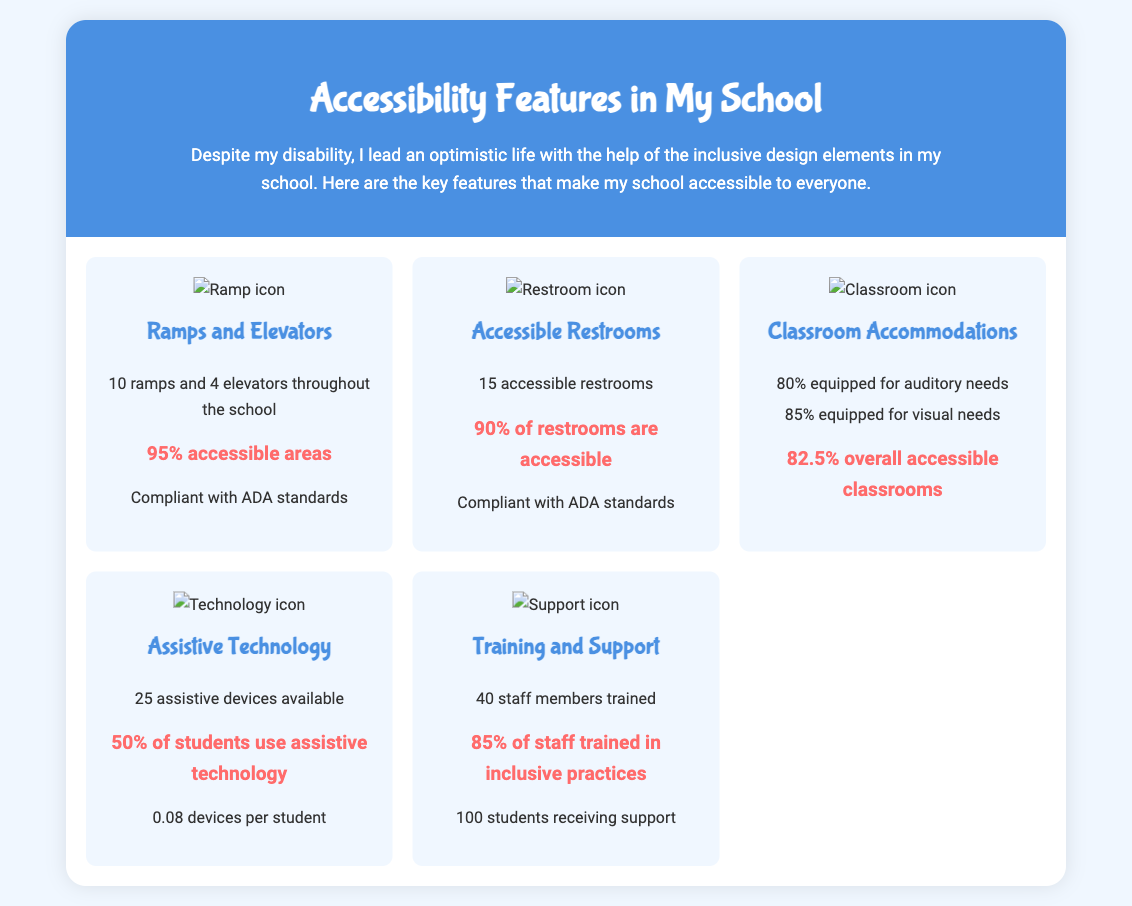How many ramps are there in the school? The document states that there are 10 ramps throughout the school.
Answer: 10 ramps What percentage of areas are accessible? According to the infographic, 95% of the areas are accessible.
Answer: 95% How many accessible restrooms are available? The document mentions there are 15 accessible restrooms.
Answer: 15 accessible restrooms What is the percentage of staff trained in inclusive practices? The infographic indicates that 85% of staff members are trained in inclusive practices.
Answer: 85% How many assistive devices are available? The document states that there are 25 assistive devices available.
Answer: 25 assistive devices What portion of classrooms is equipped for auditory needs? It is noted that 80% of classrooms are equipped for auditory needs.
Answer: 80% How many students are receiving support? The document mentions that 100 students are receiving support.
Answer: 100 students How many elevators are there? The infographic lists 4 elevators available throughout the school.
Answer: 4 elevators What is the overall percentage of accessible classrooms? According to the document, 82.5% of the classrooms are overall accessible.
Answer: 82.5% 